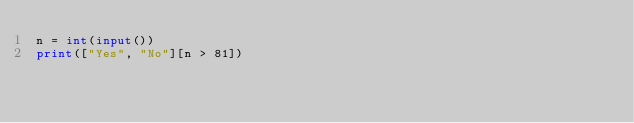<code> <loc_0><loc_0><loc_500><loc_500><_Python_>n = int(input())
print(["Yes", "No"][n > 81])
</code> 